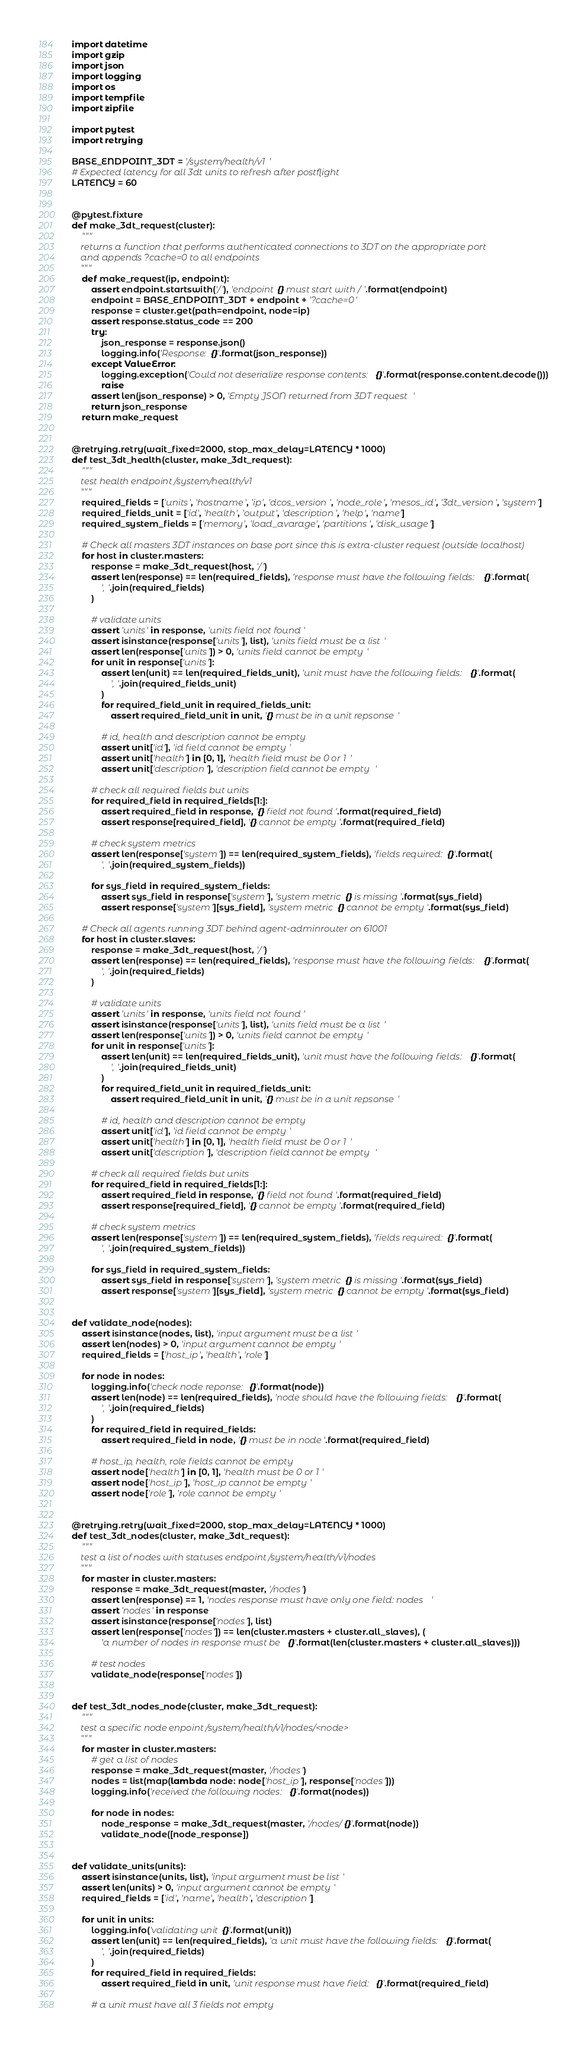<code> <loc_0><loc_0><loc_500><loc_500><_Python_>import datetime
import gzip
import json
import logging
import os
import tempfile
import zipfile

import pytest
import retrying

BASE_ENDPOINT_3DT = '/system/health/v1'
# Expected latency for all 3dt units to refresh after postflight
LATENCY = 60


@pytest.fixture
def make_3dt_request(cluster):
    """
    returns a function that performs authenticated connections to 3DT on the appropriate port
    and appends ?cache=0 to all endpoints
    """
    def make_request(ip, endpoint):
        assert endpoint.startswith('/'), 'endpoint {} must start with /'.format(endpoint)
        endpoint = BASE_ENDPOINT_3DT + endpoint + '?cache=0'
        response = cluster.get(path=endpoint, node=ip)
        assert response.status_code == 200
        try:
            json_response = response.json()
            logging.info('Response: {}'.format(json_response))
        except ValueError:
            logging.exception('Could not deserialize response contents:{}'.format(response.content.decode()))
            raise
        assert len(json_response) > 0, 'Empty JSON returned from 3DT request'
        return json_response
    return make_request


@retrying.retry(wait_fixed=2000, stop_max_delay=LATENCY * 1000)
def test_3dt_health(cluster, make_3dt_request):
    """
    test health endpoint /system/health/v1
    """
    required_fields = ['units', 'hostname', 'ip', 'dcos_version', 'node_role', 'mesos_id', '3dt_version', 'system']
    required_fields_unit = ['id', 'health', 'output', 'description', 'help', 'name']
    required_system_fields = ['memory', 'load_avarage', 'partitions', 'disk_usage']

    # Check all masters 3DT instances on base port since this is extra-cluster request (outside localhost)
    for host in cluster.masters:
        response = make_3dt_request(host, '/')
        assert len(response) == len(required_fields), 'response must have the following fields: {}'.format(
            ', '.join(required_fields)
        )

        # validate units
        assert 'units' in response, 'units field not found'
        assert isinstance(response['units'], list), 'units field must be a list'
        assert len(response['units']) > 0, 'units field cannot be empty'
        for unit in response['units']:
            assert len(unit) == len(required_fields_unit), 'unit must have the following fields: {}'.format(
                ', '.join(required_fields_unit)
            )
            for required_field_unit in required_fields_unit:
                assert required_field_unit in unit, '{} must be in a unit repsonse'

            # id, health and description cannot be empty
            assert unit['id'], 'id field cannot be empty'
            assert unit['health'] in [0, 1], 'health field must be 0 or 1'
            assert unit['description'], 'description field cannot be empty'

        # check all required fields but units
        for required_field in required_fields[1:]:
            assert required_field in response, '{} field not found'.format(required_field)
            assert response[required_field], '{} cannot be empty'.format(required_field)

        # check system metrics
        assert len(response['system']) == len(required_system_fields), 'fields required: {}'.format(
            ', '.join(required_system_fields))

        for sys_field in required_system_fields:
            assert sys_field in response['system'], 'system metric {} is missing'.format(sys_field)
            assert response['system'][sys_field], 'system metric {} cannot be empty'.format(sys_field)

    # Check all agents running 3DT behind agent-adminrouter on 61001
    for host in cluster.slaves:
        response = make_3dt_request(host, '/')
        assert len(response) == len(required_fields), 'response must have the following fields: {}'.format(
            ', '.join(required_fields)
        )

        # validate units
        assert 'units' in response, 'units field not found'
        assert isinstance(response['units'], list), 'units field must be a list'
        assert len(response['units']) > 0, 'units field cannot be empty'
        for unit in response['units']:
            assert len(unit) == len(required_fields_unit), 'unit must have the following fields: {}'.format(
                ', '.join(required_fields_unit)
            )
            for required_field_unit in required_fields_unit:
                assert required_field_unit in unit, '{} must be in a unit repsonse'

            # id, health and description cannot be empty
            assert unit['id'], 'id field cannot be empty'
            assert unit['health'] in [0, 1], 'health field must be 0 or 1'
            assert unit['description'], 'description field cannot be empty'

        # check all required fields but units
        for required_field in required_fields[1:]:
            assert required_field in response, '{} field not found'.format(required_field)
            assert response[required_field], '{} cannot be empty'.format(required_field)

        # check system metrics
        assert len(response['system']) == len(required_system_fields), 'fields required: {}'.format(
            ', '.join(required_system_fields))

        for sys_field in required_system_fields:
            assert sys_field in response['system'], 'system metric {} is missing'.format(sys_field)
            assert response['system'][sys_field], 'system metric {} cannot be empty'.format(sys_field)


def validate_node(nodes):
    assert isinstance(nodes, list), 'input argument must be a list'
    assert len(nodes) > 0, 'input argument cannot be empty'
    required_fields = ['host_ip', 'health', 'role']

    for node in nodes:
        logging.info('check node reponse: {}'.format(node))
        assert len(node) == len(required_fields), 'node should have the following fields: {}'.format(
            ', '.join(required_fields)
        )
        for required_field in required_fields:
            assert required_field in node, '{} must be in node'.format(required_field)

        # host_ip, health, role fields cannot be empty
        assert node['health'] in [0, 1], 'health must be 0 or 1'
        assert node['host_ip'], 'host_ip cannot be empty'
        assert node['role'], 'role cannot be empty'


@retrying.retry(wait_fixed=2000, stop_max_delay=LATENCY * 1000)
def test_3dt_nodes(cluster, make_3dt_request):
    """
    test a list of nodes with statuses endpoint /system/health/v1/nodes
    """
    for master in cluster.masters:
        response = make_3dt_request(master, '/nodes')
        assert len(response) == 1, 'nodes response must have only one field: nodes'
        assert 'nodes' in response
        assert isinstance(response['nodes'], list)
        assert len(response['nodes']) == len(cluster.masters + cluster.all_slaves), (
            'a number of nodes in response must be {}'.format(len(cluster.masters + cluster.all_slaves)))

        # test nodes
        validate_node(response['nodes'])


def test_3dt_nodes_node(cluster, make_3dt_request):
    """
    test a specific node enpoint /system/health/v1/nodes/<node>
    """
    for master in cluster.masters:
        # get a list of nodes
        response = make_3dt_request(master, '/nodes')
        nodes = list(map(lambda node: node['host_ip'], response['nodes']))
        logging.info('received the following nodes: {}'.format(nodes))

        for node in nodes:
            node_response = make_3dt_request(master, '/nodes/{}'.format(node))
            validate_node([node_response])


def validate_units(units):
    assert isinstance(units, list), 'input argument must be list'
    assert len(units) > 0, 'input argument cannot be empty'
    required_fields = ['id', 'name', 'health', 'description']

    for unit in units:
        logging.info('validating unit {}'.format(unit))
        assert len(unit) == len(required_fields), 'a unit must have the following fields: {}'.format(
            ', '.join(required_fields)
        )
        for required_field in required_fields:
            assert required_field in unit, 'unit response must have field: {}'.format(required_field)

        # a unit must have all 3 fields not empty</code> 